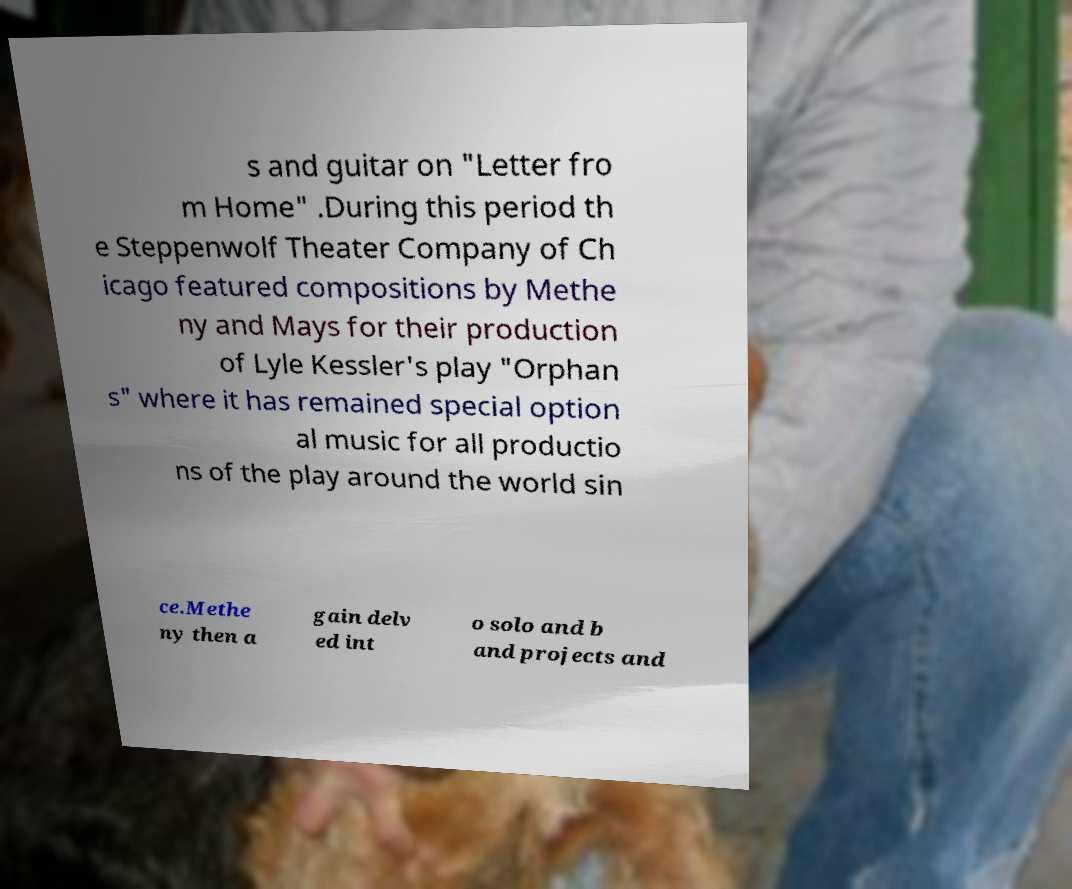Can you accurately transcribe the text from the provided image for me? s and guitar on "Letter fro m Home" .During this period th e Steppenwolf Theater Company of Ch icago featured compositions by Methe ny and Mays for their production of Lyle Kessler's play "Orphan s" where it has remained special option al music for all productio ns of the play around the world sin ce.Methe ny then a gain delv ed int o solo and b and projects and 